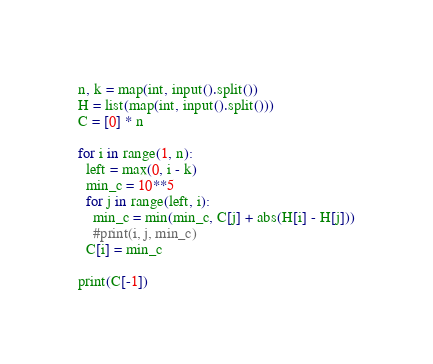Convert code to text. <code><loc_0><loc_0><loc_500><loc_500><_Python_>n, k = map(int, input().split())
H = list(map(int, input().split()))
C = [0] * n

for i in range(1, n):
  left = max(0, i - k)
  min_c = 10**5
  for j in range(left, i):
    min_c = min(min_c, C[j] + abs(H[i] - H[j]))
    #print(i, j, min_c)
  C[i] = min_c
  
print(C[-1])</code> 